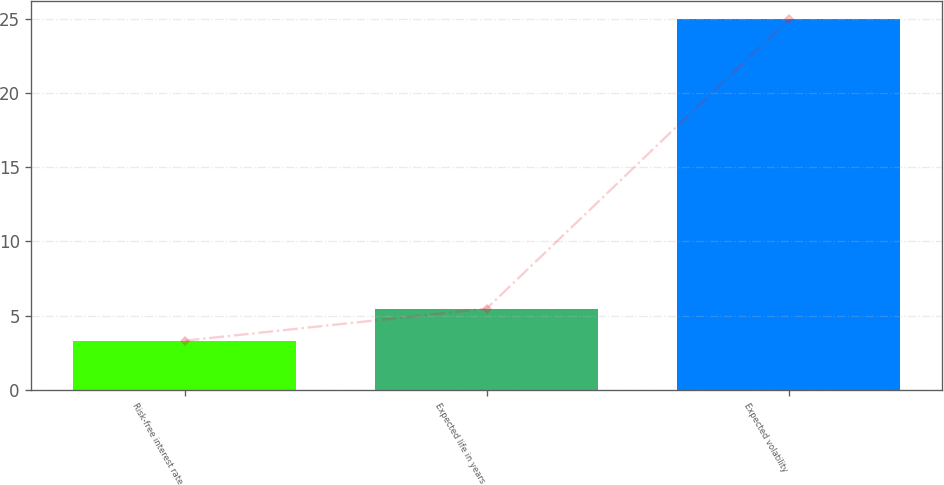Convert chart. <chart><loc_0><loc_0><loc_500><loc_500><bar_chart><fcel>Risk-free interest rate<fcel>Expected life in years<fcel>Expected volatility<nl><fcel>3.3<fcel>5.47<fcel>25<nl></chart> 